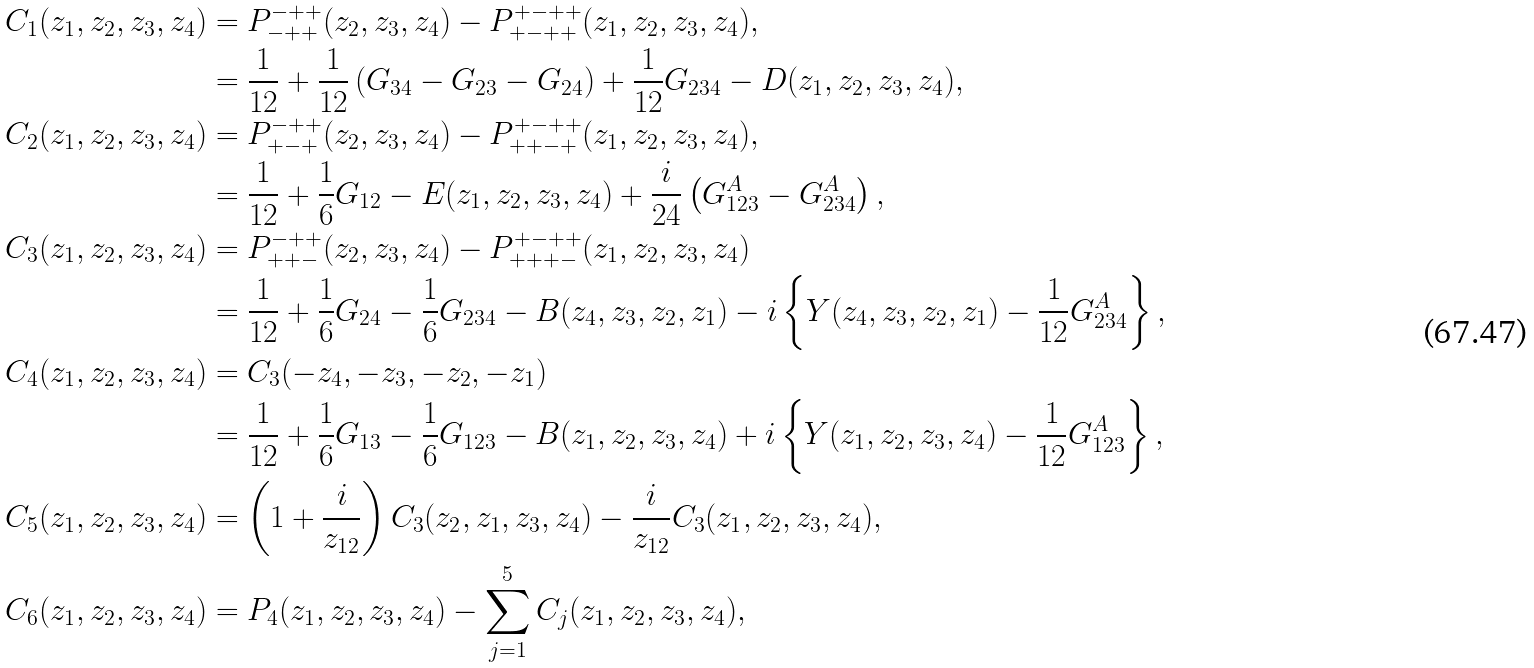Convert formula to latex. <formula><loc_0><loc_0><loc_500><loc_500>C _ { 1 } ( z _ { 1 } , z _ { 2 } , z _ { 3 } , z _ { 4 } ) & = P _ { - + + } ^ { - + + } ( z _ { 2 } , z _ { 3 } , z _ { 4 } ) - P _ { + - + + } ^ { + - + + } ( z _ { 1 } , z _ { 2 } , z _ { 3 } , z _ { 4 } ) , \\ & = \frac { 1 } { 1 2 } + \frac { 1 } { 1 2 } \left ( G _ { 3 4 } - G _ { 2 3 } - G _ { 2 4 } \right ) + \frac { 1 } { 1 2 } G _ { 2 3 4 } - D ( z _ { 1 } , z _ { 2 } , z _ { 3 } , z _ { 4 } ) , \\ C _ { 2 } ( z _ { 1 } , z _ { 2 } , z _ { 3 } , z _ { 4 } ) & = P _ { + - + } ^ { - + + } ( z _ { 2 } , z _ { 3 } , z _ { 4 } ) - P _ { + + - + } ^ { + - + + } ( z _ { 1 } , z _ { 2 } , z _ { 3 } , z _ { 4 } ) , \\ & = \frac { 1 } { 1 2 } + \frac { 1 } { 6 } G _ { 1 2 } - E ( z _ { 1 } , z _ { 2 } , z _ { 3 } , z _ { 4 } ) + \frac { i } { 2 4 } \left ( G _ { 1 2 3 } ^ { A } - G _ { 2 3 4 } ^ { A } \right ) , \\ C _ { 3 } ( z _ { 1 } , z _ { 2 } , z _ { 3 } , z _ { 4 } ) & = P _ { + + - } ^ { - + + } ( z _ { 2 } , z _ { 3 } , z _ { 4 } ) - P _ { + + + - } ^ { + - + + } ( z _ { 1 } , z _ { 2 } , z _ { 3 } , z _ { 4 } ) \\ & = \frac { 1 } { 1 2 } + \frac { 1 } { 6 } G _ { 2 4 } - \frac { 1 } { 6 } G _ { 2 3 4 } - B ( z _ { 4 } , z _ { 3 } , z _ { 2 } , z _ { 1 } ) - i \left \{ Y ( z _ { 4 } , z _ { 3 } , z _ { 2 } , z _ { 1 } ) - \frac { 1 } { 1 2 } G _ { 2 3 4 } ^ { A } \right \} , \\ C _ { 4 } ( z _ { 1 } , z _ { 2 } , z _ { 3 } , z _ { 4 } ) & = C _ { 3 } ( - z _ { 4 } , - z _ { 3 } , - z _ { 2 } , - z _ { 1 } ) \\ & = \frac { 1 } { 1 2 } + \frac { 1 } { 6 } G _ { 1 3 } - \frac { 1 } { 6 } G _ { 1 2 3 } - B ( z _ { 1 } , z _ { 2 } , z _ { 3 } , z _ { 4 } ) + i \left \{ Y ( z _ { 1 } , z _ { 2 } , z _ { 3 } , z _ { 4 } ) - \frac { 1 } { 1 2 } G _ { 1 2 3 } ^ { A } \right \} , \\ C _ { 5 } ( z _ { 1 } , z _ { 2 } , z _ { 3 } , z _ { 4 } ) & = \left ( 1 + \frac { i } { z _ { 1 2 } } \right ) C _ { 3 } ( z _ { 2 } , z _ { 1 } , z _ { 3 } , z _ { 4 } ) - \frac { i } { z _ { 1 2 } } C _ { 3 } ( z _ { 1 } , z _ { 2 } , z _ { 3 } , z _ { 4 } ) , \\ C _ { 6 } ( z _ { 1 } , z _ { 2 } , z _ { 3 } , z _ { 4 } ) & = P _ { 4 } ( z _ { 1 } , z _ { 2 } , z _ { 3 } , z _ { 4 } ) - \sum _ { j = 1 } ^ { 5 } C _ { j } ( z _ { 1 } , z _ { 2 } , z _ { 3 } , z _ { 4 } ) ,</formula> 